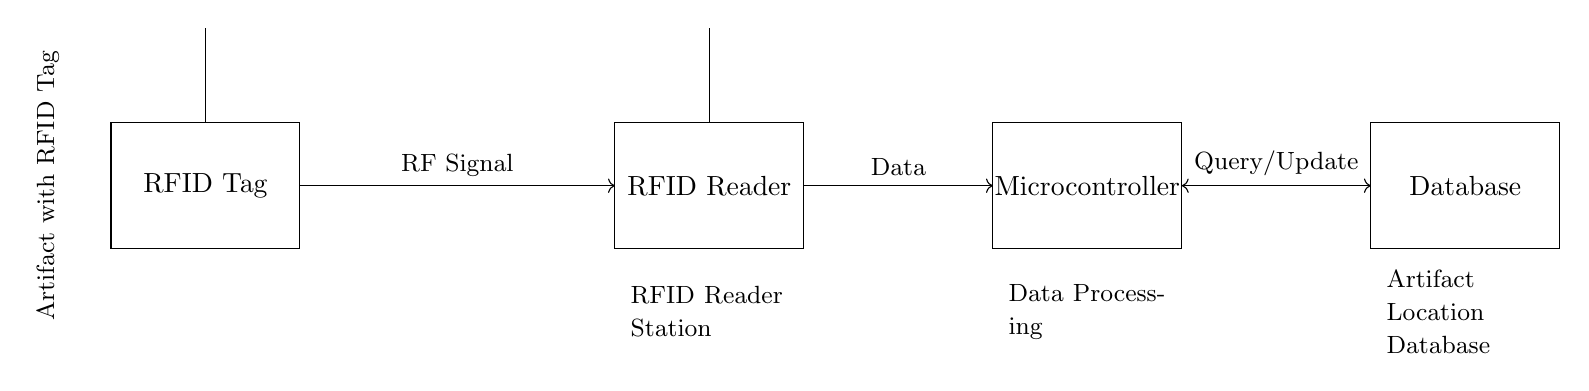What component is used for communication between the RFID Tag and Reader? The RFID Tag communicates with the Reader using radio frequency signals, which is facilitated by antennas present in both components.
Answer: Antenna What connects the RFID Reader to the Microcontroller? The RFID Reader sends data to the Microcontroller through a data connection indicated by the arrow in the diagram, which represents the flow of information.
Answer: Data How many main components are visible in the circuit diagram? There are four main components in the circuit diagram: RFID Tag, RFID Reader, Microcontroller, and Database. Each has a distinct function in the system.
Answer: Four What type of signal is transmitted from the RFID Tag to the RFID Reader? The transmission type from the RFID Tag to the RFID Reader is a radio frequency (RF) signal, which allows for wireless communication between these components.
Answer: RF Signal What is the primary function of the Database in this RFID system? The Database is responsible for storing and managing information regarding the artifact locations, allowing for queries and updates about the RFID Tag data.
Answer: Location Management Which direction does the data flow between the Microcontroller and Database? The data flows both ways between the Microcontroller and Database, as indicated by the bidirectional arrow in the diagram, allowing for updates and queries.
Answer: Bidirectional What does the rectangle labeled 'Microcontroller' signify in the circuit? The 'Microcontroller' rectangle signifies the component responsible for processing the data received from the RFID Reader and managing communications with the Database.
Answer: Data Processing 